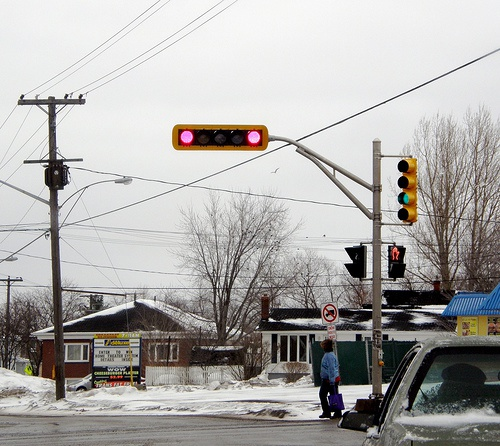Describe the objects in this image and their specific colors. I can see car in white, black, gray, and darkgray tones, traffic light in white, black, olive, violet, and maroon tones, traffic light in white, black, olive, orange, and gainsboro tones, people in white, black, navy, blue, and gray tones, and traffic light in white, black, gray, and darkgray tones in this image. 